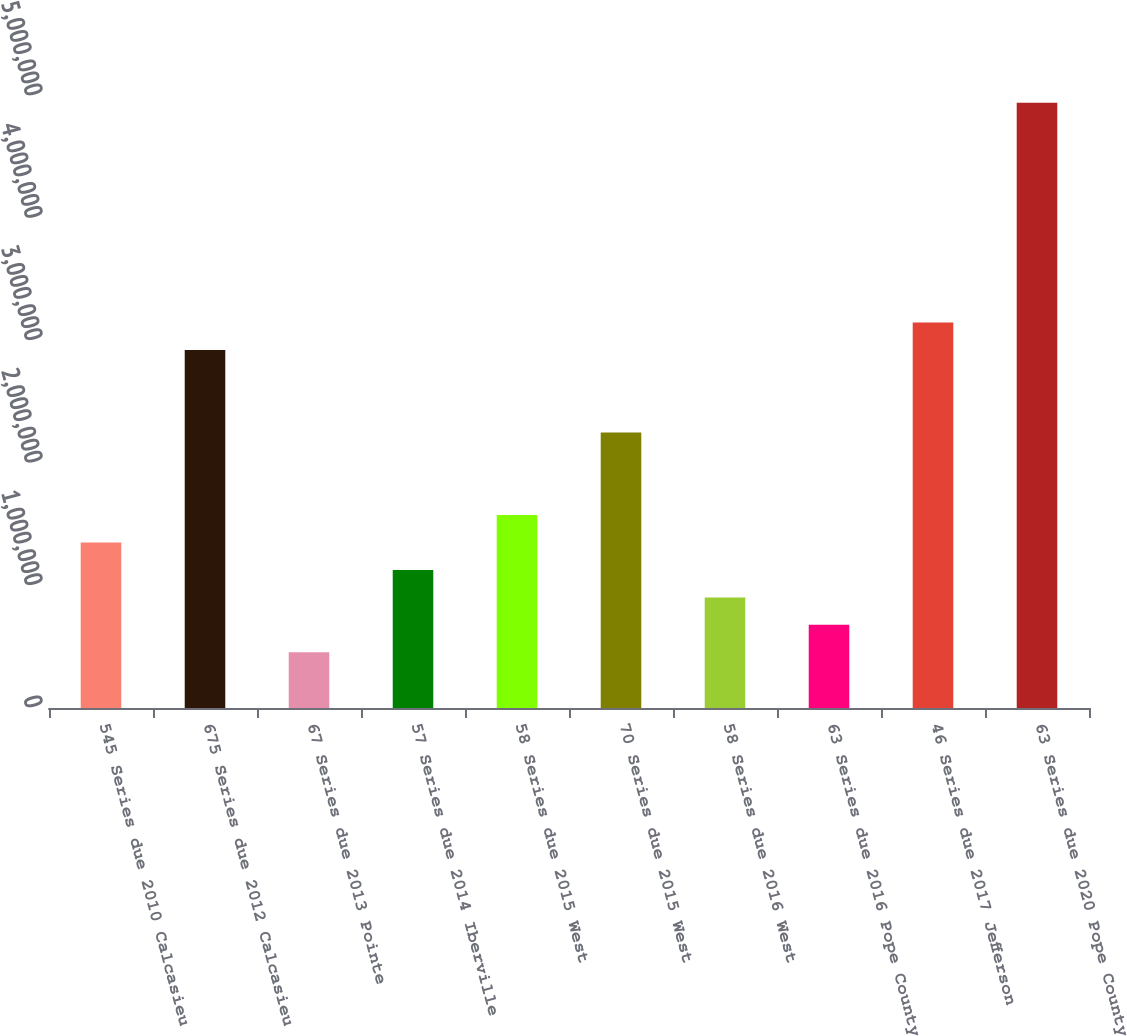Convert chart to OTSL. <chart><loc_0><loc_0><loc_500><loc_500><bar_chart><fcel>545 Series due 2010 Calcasieu<fcel>675 Series due 2012 Calcasieu<fcel>67 Series due 2013 Pointe<fcel>57 Series due 2014 Iberville<fcel>58 Series due 2015 West<fcel>70 Series due 2015 West<fcel>58 Series due 2016 West<fcel>63 Series due 2016 Pope County<fcel>46 Series due 2017 Jefferson<fcel>63 Series due 2020 Pope County<nl><fcel>1.35284e+06<fcel>2.92462e+06<fcel>454677<fcel>1.1283e+06<fcel>1.57738e+06<fcel>2.251e+06<fcel>903758<fcel>679217<fcel>3.14916e+06<fcel>4.94548e+06<nl></chart> 